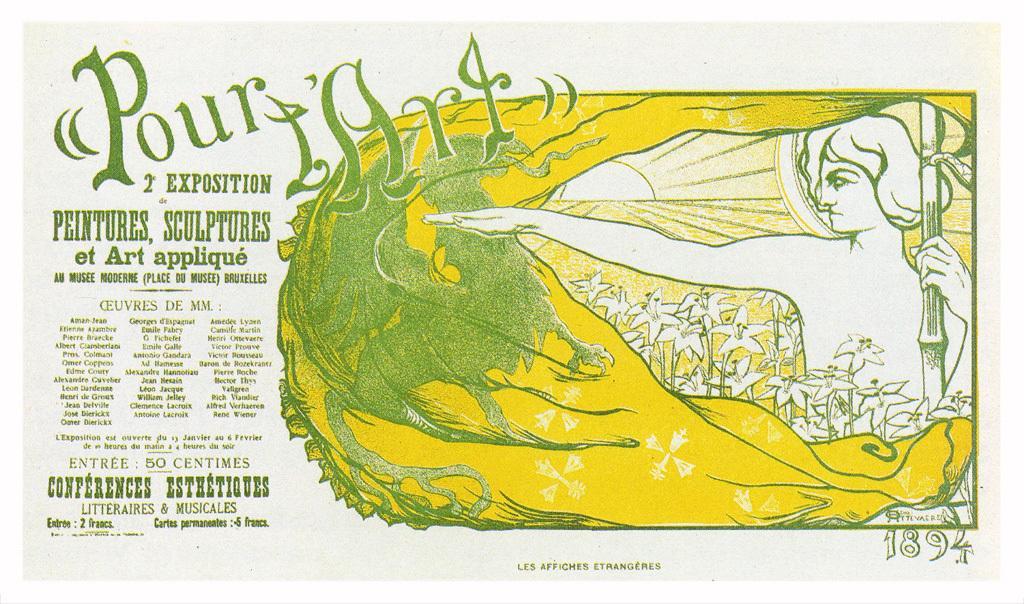Can you describe this image briefly? In this picture I can see a poster with some text and a picture. 